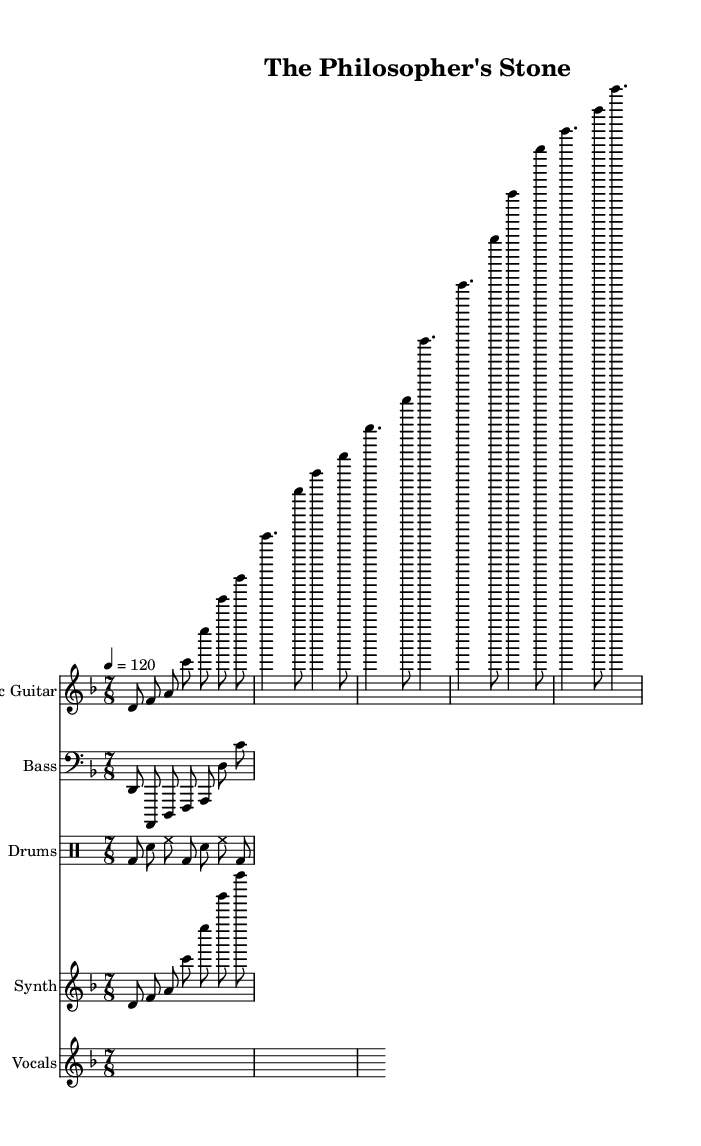What is the key signature of this music? The key signature is indicated in the global section of the code as D minor, which typically includes one flat (B flat).
Answer: D minor What is the time signature of this music? The time signature is also stated in the global section, noted as 7/8, meaning there are seven eighth notes per measure.
Answer: 7/8 What is the tempo marking for this piece? The tempo marking is found in the global section, written as "4 = 120," indicating that there are 120 beats per minute, aligning with a quarter note.
Answer: 120 How many measures are in the verse section of the music? The verse section contains two measures as determined by examining the electric guitar part which demonstrates the verse rhythm for the same duration.
Answer: 2 What is the first note of the introduction? The first note in the introduction appears in the electric guitar part and is D in the octave indicated, showing it starts with this note.
Answer: D How many instruments are featured in this piece? The score section lists four instruments: Electric Guitar, Bass, Drums, and Synth, making a total of four distinct instruments.
Answer: 4 What thematic concept is explored in the lyrics? The lyrics mention "truth" and "reason," hinting at themes of philosophical exploration and existential inquiry, which are characteristic of progressive rock narratives.
Answer: Philosophical exploration 